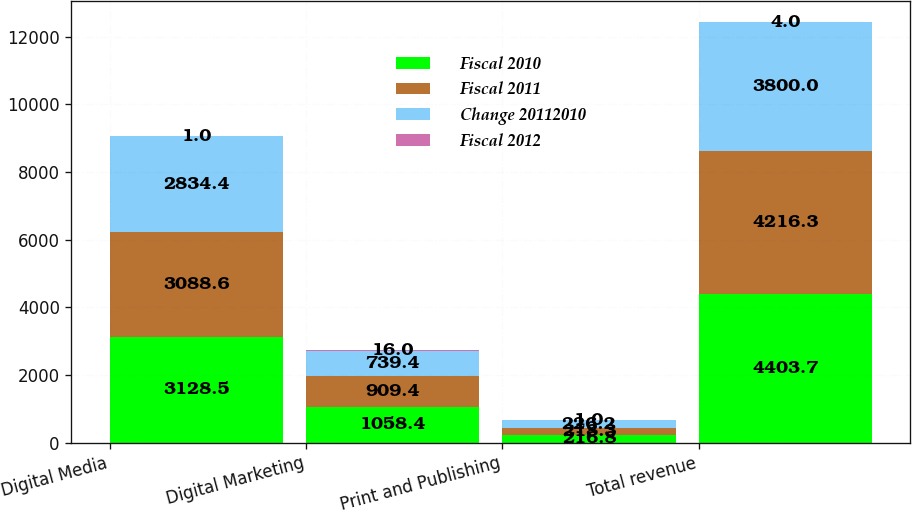Convert chart to OTSL. <chart><loc_0><loc_0><loc_500><loc_500><stacked_bar_chart><ecel><fcel>Digital Media<fcel>Digital Marketing<fcel>Print and Publishing<fcel>Total revenue<nl><fcel>Fiscal 2010<fcel>3128.5<fcel>1058.4<fcel>216.8<fcel>4403.7<nl><fcel>Fiscal 2011<fcel>3088.6<fcel>909.4<fcel>218.3<fcel>4216.3<nl><fcel>Change 20112010<fcel>2834.4<fcel>739.4<fcel>226.2<fcel>3800<nl><fcel>Fiscal 2012<fcel>1<fcel>16<fcel>1<fcel>4<nl></chart> 